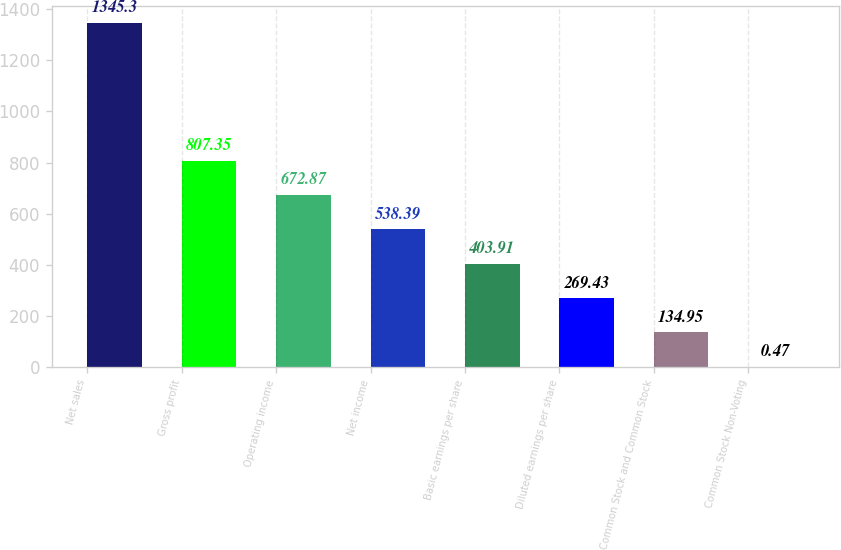<chart> <loc_0><loc_0><loc_500><loc_500><bar_chart><fcel>Net sales<fcel>Gross profit<fcel>Operating income<fcel>Net income<fcel>Basic earnings per share<fcel>Diluted earnings per share<fcel>Common Stock and Common Stock<fcel>Common Stock Non-Voting<nl><fcel>1345.3<fcel>807.35<fcel>672.87<fcel>538.39<fcel>403.91<fcel>269.43<fcel>134.95<fcel>0.47<nl></chart> 